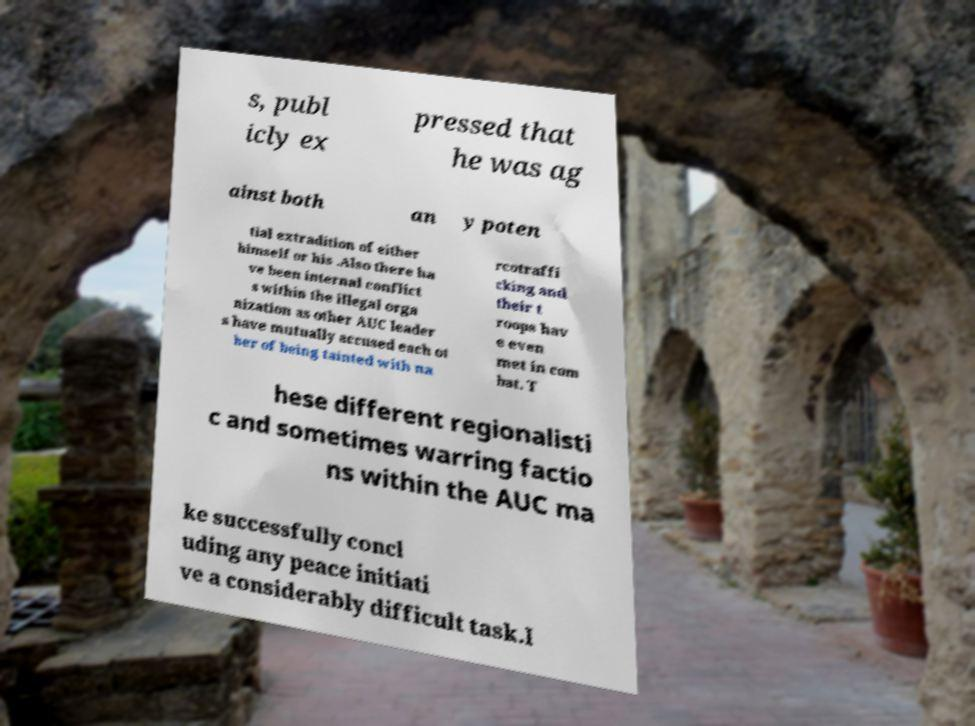Please read and relay the text visible in this image. What does it say? s, publ icly ex pressed that he was ag ainst both an y poten tial extradition of either himself or his .Also there ha ve been internal conflict s within the illegal orga nization as other AUC leader s have mutually accused each ot her of being tainted with na rcotraffi cking and their t roops hav e even met in com bat. T hese different regionalisti c and sometimes warring factio ns within the AUC ma ke successfully concl uding any peace initiati ve a considerably difficult task.I 